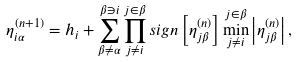Convert formula to latex. <formula><loc_0><loc_0><loc_500><loc_500>\eta ^ { ( n + 1 ) } _ { i \alpha } = h _ { i } + \sum _ { \beta \neq \alpha } ^ { \beta \ni i } \prod _ { j \neq i } ^ { j \in \beta } s i g n \left [ \eta ^ { ( n ) } _ { j \beta } \right ] \min _ { j \neq i } ^ { j \in \beta } \left | \eta ^ { ( n ) } _ { j \beta } \right | ,</formula> 